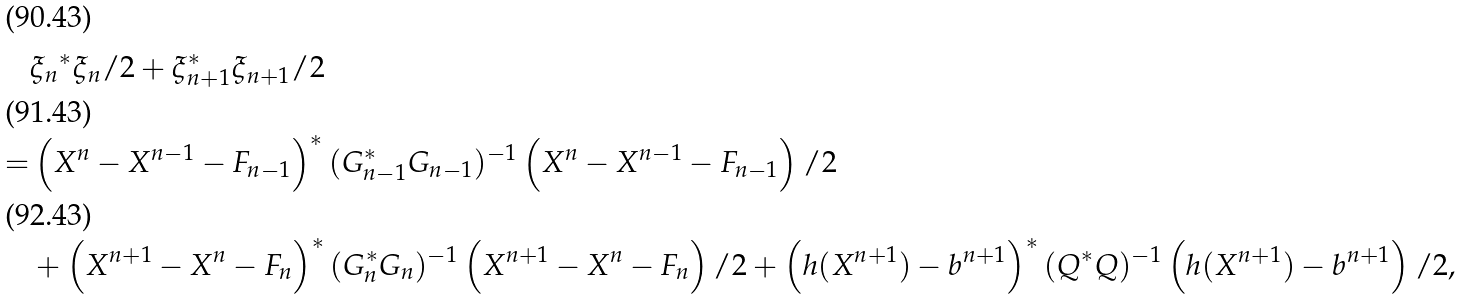<formula> <loc_0><loc_0><loc_500><loc_500>& { \xi _ { n } } ^ { * } \xi _ { n } / 2 + \xi _ { n + 1 } ^ { * } \xi _ { n + 1 } / 2 \\ = & \left ( X ^ { n } - X ^ { n - 1 } - F _ { n - 1 } \right ) ^ { * } ( G _ { n - 1 } ^ { * } G _ { n - 1 } ) ^ { - 1 } \left ( X ^ { n } - X ^ { n - 1 } - F _ { n - 1 } \right ) / 2 \\ & + \left ( X ^ { n + 1 } - X ^ { n } - F _ { n } \right ) ^ { * } ( G _ { n } ^ { * } G _ { n } ) ^ { - 1 } \left ( X ^ { n + 1 } - X ^ { n } - F _ { n } \right ) / 2 + \left ( h ( X ^ { n + 1 } ) - b ^ { n + 1 } \right ) ^ { * } ( Q ^ { * } Q ) ^ { - 1 } \left ( h ( X ^ { n + 1 } ) - b ^ { n + 1 } \right ) / 2 ,</formula> 